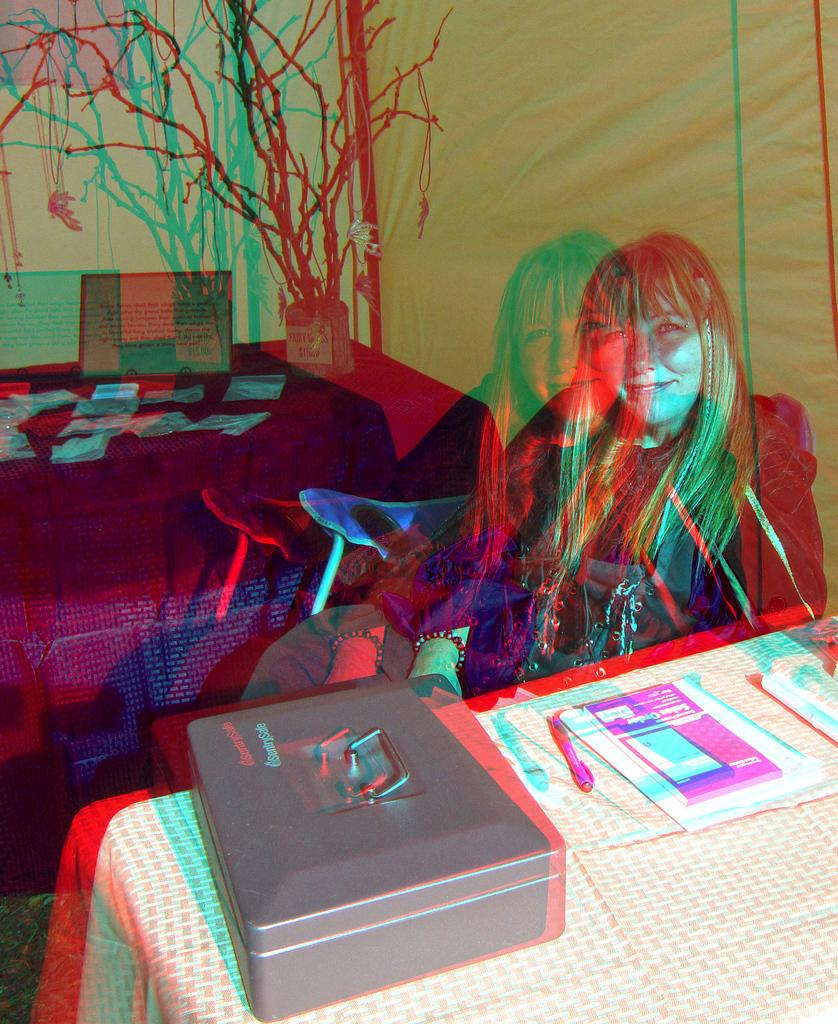Who is in the image? There is a lady in the image. What objects are present in the image? There are tables, papers, a box, and other items on the tables. What can be seen in the background of the image? There is a tree visible in the background of the image. What type of poison is being used to treat the star in the library in the image? There is no mention of poison, star, or library in the image. The image features a lady, tables, papers, a box, and a tree in the background. 